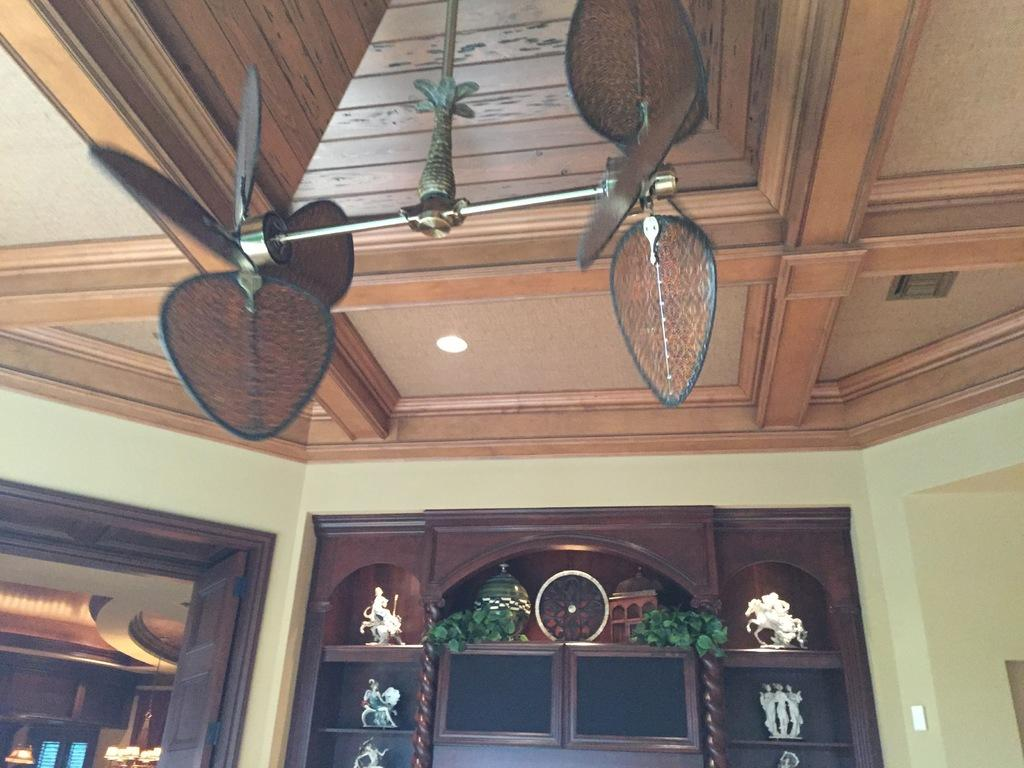What type of artwork can be seen in the image? There are sculptures in the image. What else can be seen on shelves in the image? There are plants on shelves in the image. What color are some of the objects in the image? There are brown-colored objects in the image. Can you see any waves in the image? There are no waves present in the image. What type of cakes are being displayed on the shelves with the plants? There are no cakes present in the image; only plants and sculptures can be seen. 